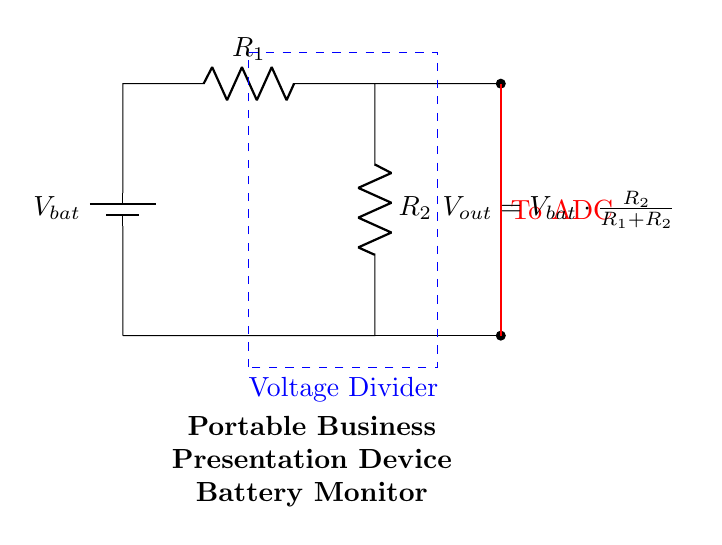What does the output voltage depend on? The output voltage is dependent on the values of the resistors R1 and R2, and the input battery voltage Vbat. The formula shows how Vout is calculated from these components.
Answer: R1, R2, Vbat What is the purpose of R1 in the circuit? R1, along with R2, forms part of the voltage divider configuration, which influences the distribution of voltage across the resistors. It helps in determining how much voltage is dropped before reaching the ADC.
Answer: Voltage division What is the value of Vout if Vbat is 9V and R1 is 1kOhm and R2 is 2kOhm? Using the voltage divider formula Vout = Vbat * (R2 / (R1 + R2)), plug in the values: Vout = 9V * (2kOhm / (1kOhm + 2kOhm)) = 6V.
Answer: 6V How many resistors are used in this voltage divider? The circuit utilizes two resistors, R1 and R2, to create the voltage division effect.
Answer: Two What type of circuit is shown in the diagram? The diagram represents a voltage divider circuit. This configuration specifically serves to monitor battery levels by scaling down the battery voltage for an Analog to Digital Converter (ADC) input.
Answer: Voltage divider What is the role of the ADC in this circuit? The ADC converts the analog output voltage from the voltage divider into a digital signal, allowing for monitoring and measurement of the battery level in a microcontroller or display system.
Answer: Measurement 